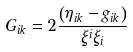Convert formula to latex. <formula><loc_0><loc_0><loc_500><loc_500>G _ { i k } = 2 \frac { \left ( \eta _ { i k } - g _ { i k } \right ) } { \xi ^ { i } \xi _ { i } }</formula> 